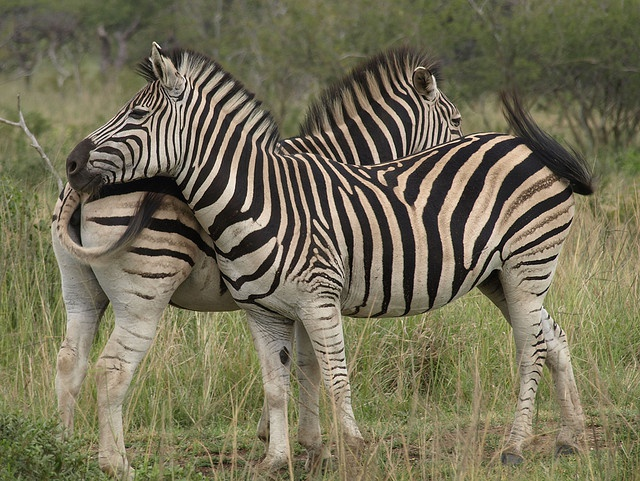Describe the objects in this image and their specific colors. I can see zebra in darkgreen, black, darkgray, gray, and tan tones and zebra in darkgreen, black, darkgray, and gray tones in this image. 